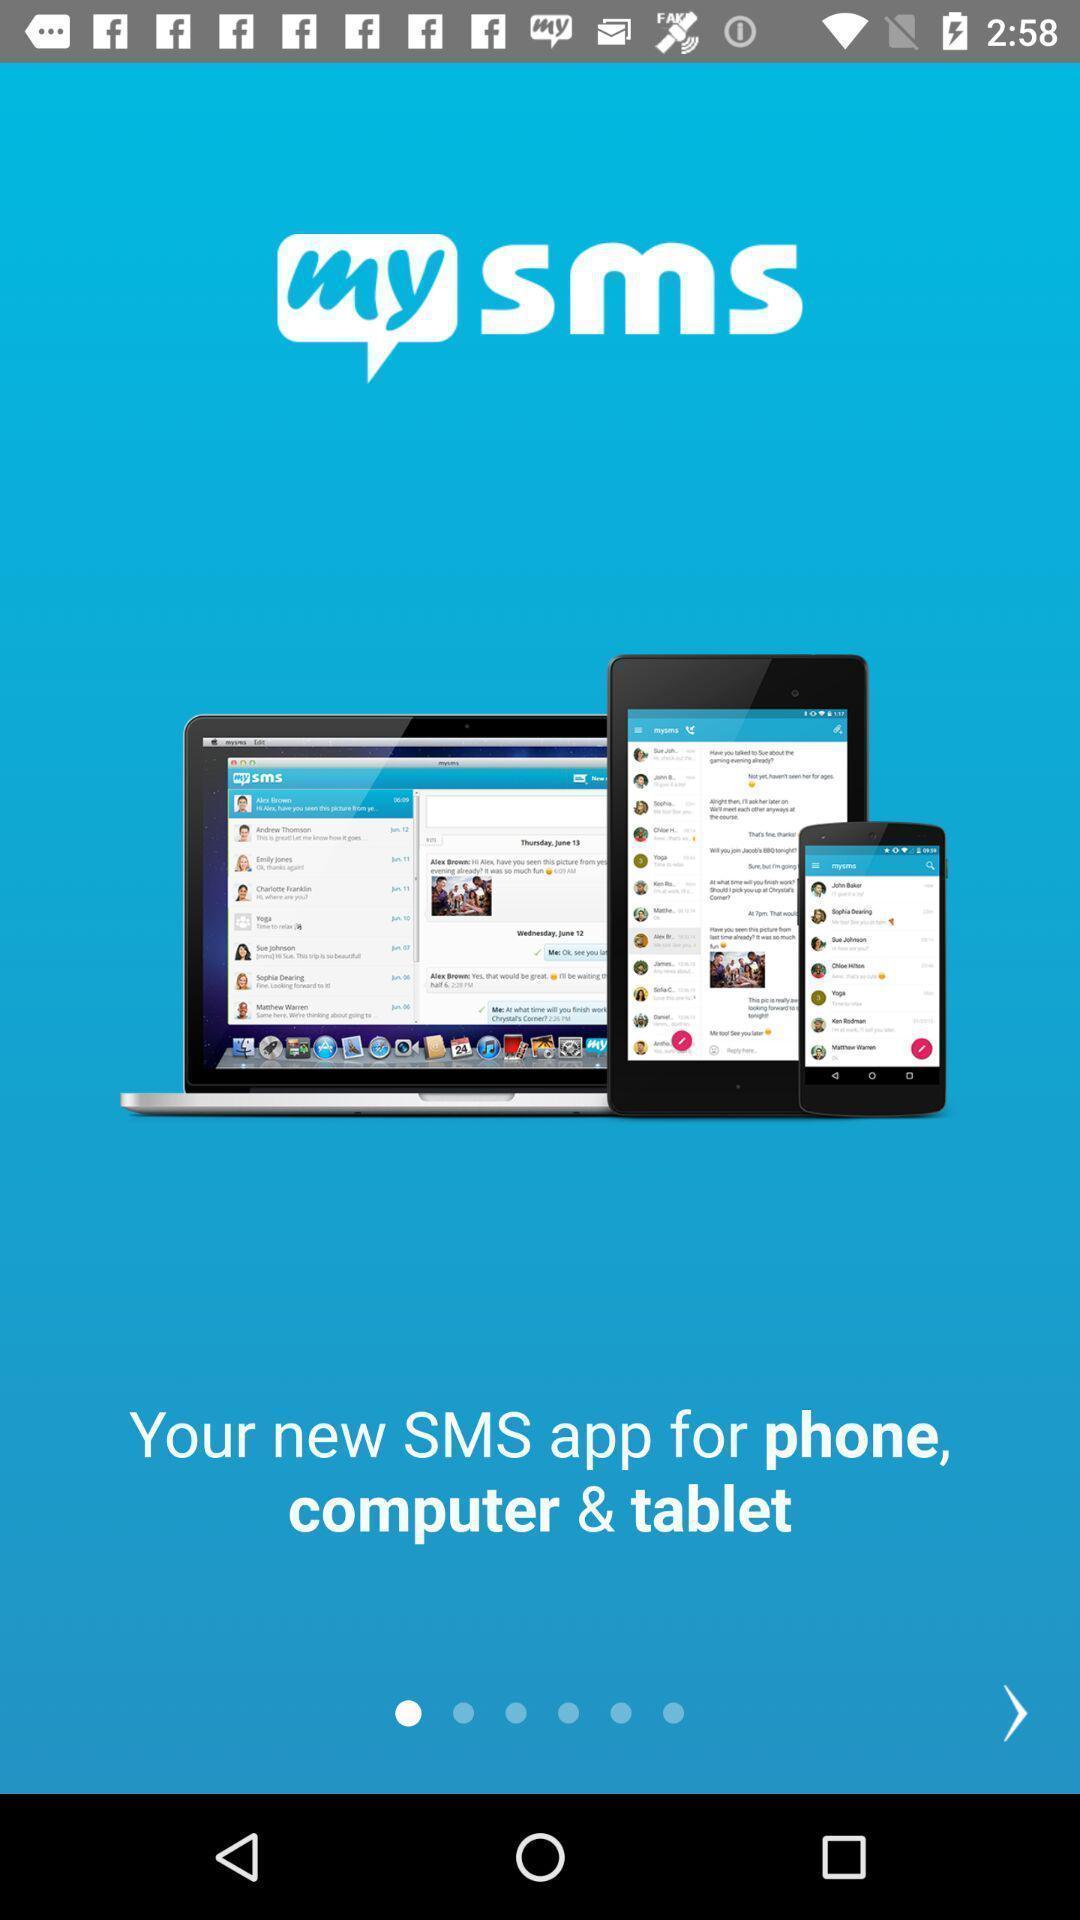Explain the elements present in this screenshot. Welcome page of s-m-s app. 